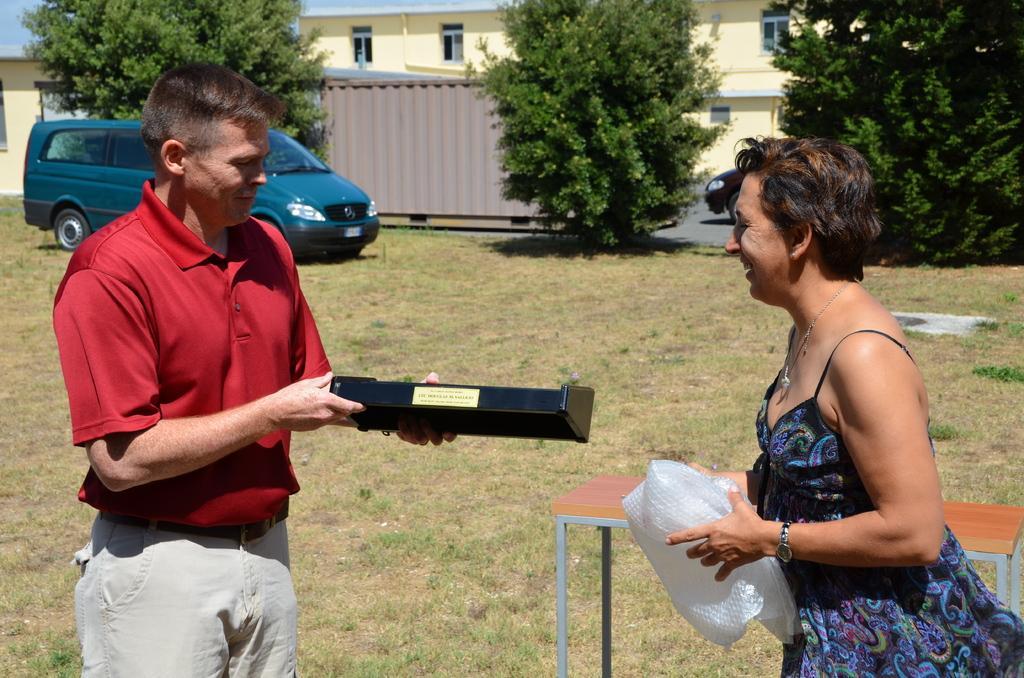Describe this image in one or two sentences. In this image we can see two persons, a woman is holding a bubble wrap, a man is holding an object with text on it, there are two cars, a table, plants, trees, there is a house, windows, also we can see the sky. 